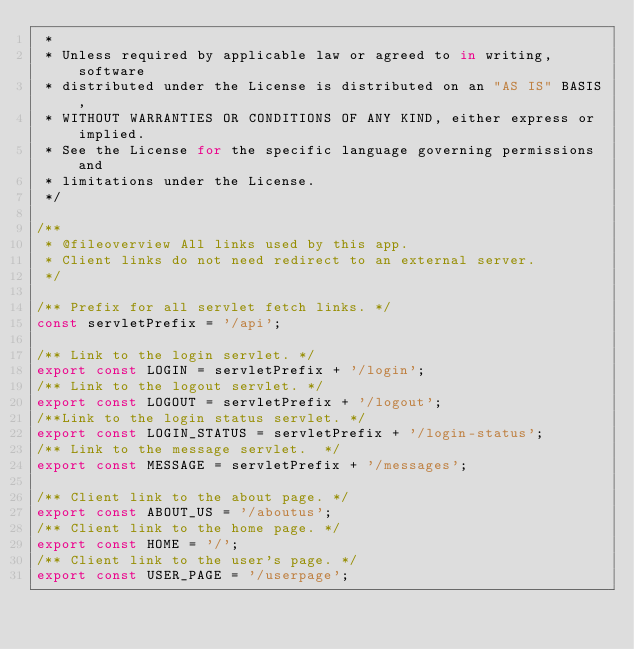Convert code to text. <code><loc_0><loc_0><loc_500><loc_500><_JavaScript_> *
 * Unless required by applicable law or agreed to in writing, software
 * distributed under the License is distributed on an "AS IS" BASIS,
 * WITHOUT WARRANTIES OR CONDITIONS OF ANY KIND, either express or implied.
 * See the License for the specific language governing permissions and
 * limitations under the License.
 */

/**
 * @fileoverview All links used by this app.
 * Client links do not need redirect to an external server.
 */

/** Prefix for all servlet fetch links. */
const servletPrefix = '/api';

/** Link to the login servlet. */
export const LOGIN = servletPrefix + '/login';
/** Link to the logout servlet. */
export const LOGOUT = servletPrefix + '/logout';
/**Link to the login status servlet. */
export const LOGIN_STATUS = servletPrefix + '/login-status';
/** Link to the message servlet.  */
export const MESSAGE = servletPrefix + '/messages';

/** Client link to the about page. */
export const ABOUT_US = '/aboutus';
/** Client link to the home page. */
export const HOME = '/';
/** Client link to the user's page. */
export const USER_PAGE = '/userpage';
</code> 